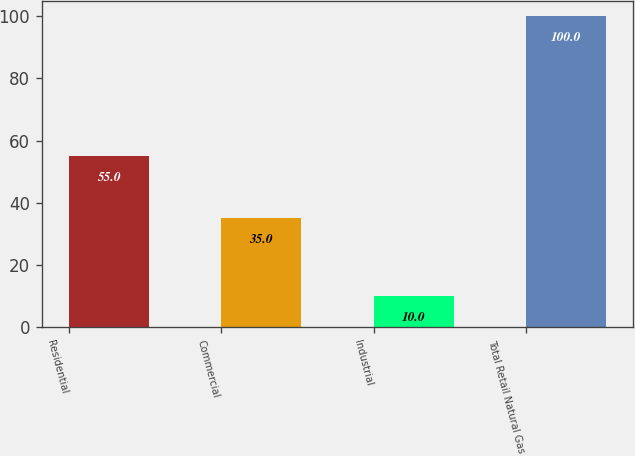Convert chart. <chart><loc_0><loc_0><loc_500><loc_500><bar_chart><fcel>Residential<fcel>Commercial<fcel>Industrial<fcel>Total Retail Natural Gas<nl><fcel>55<fcel>35<fcel>10<fcel>100<nl></chart> 